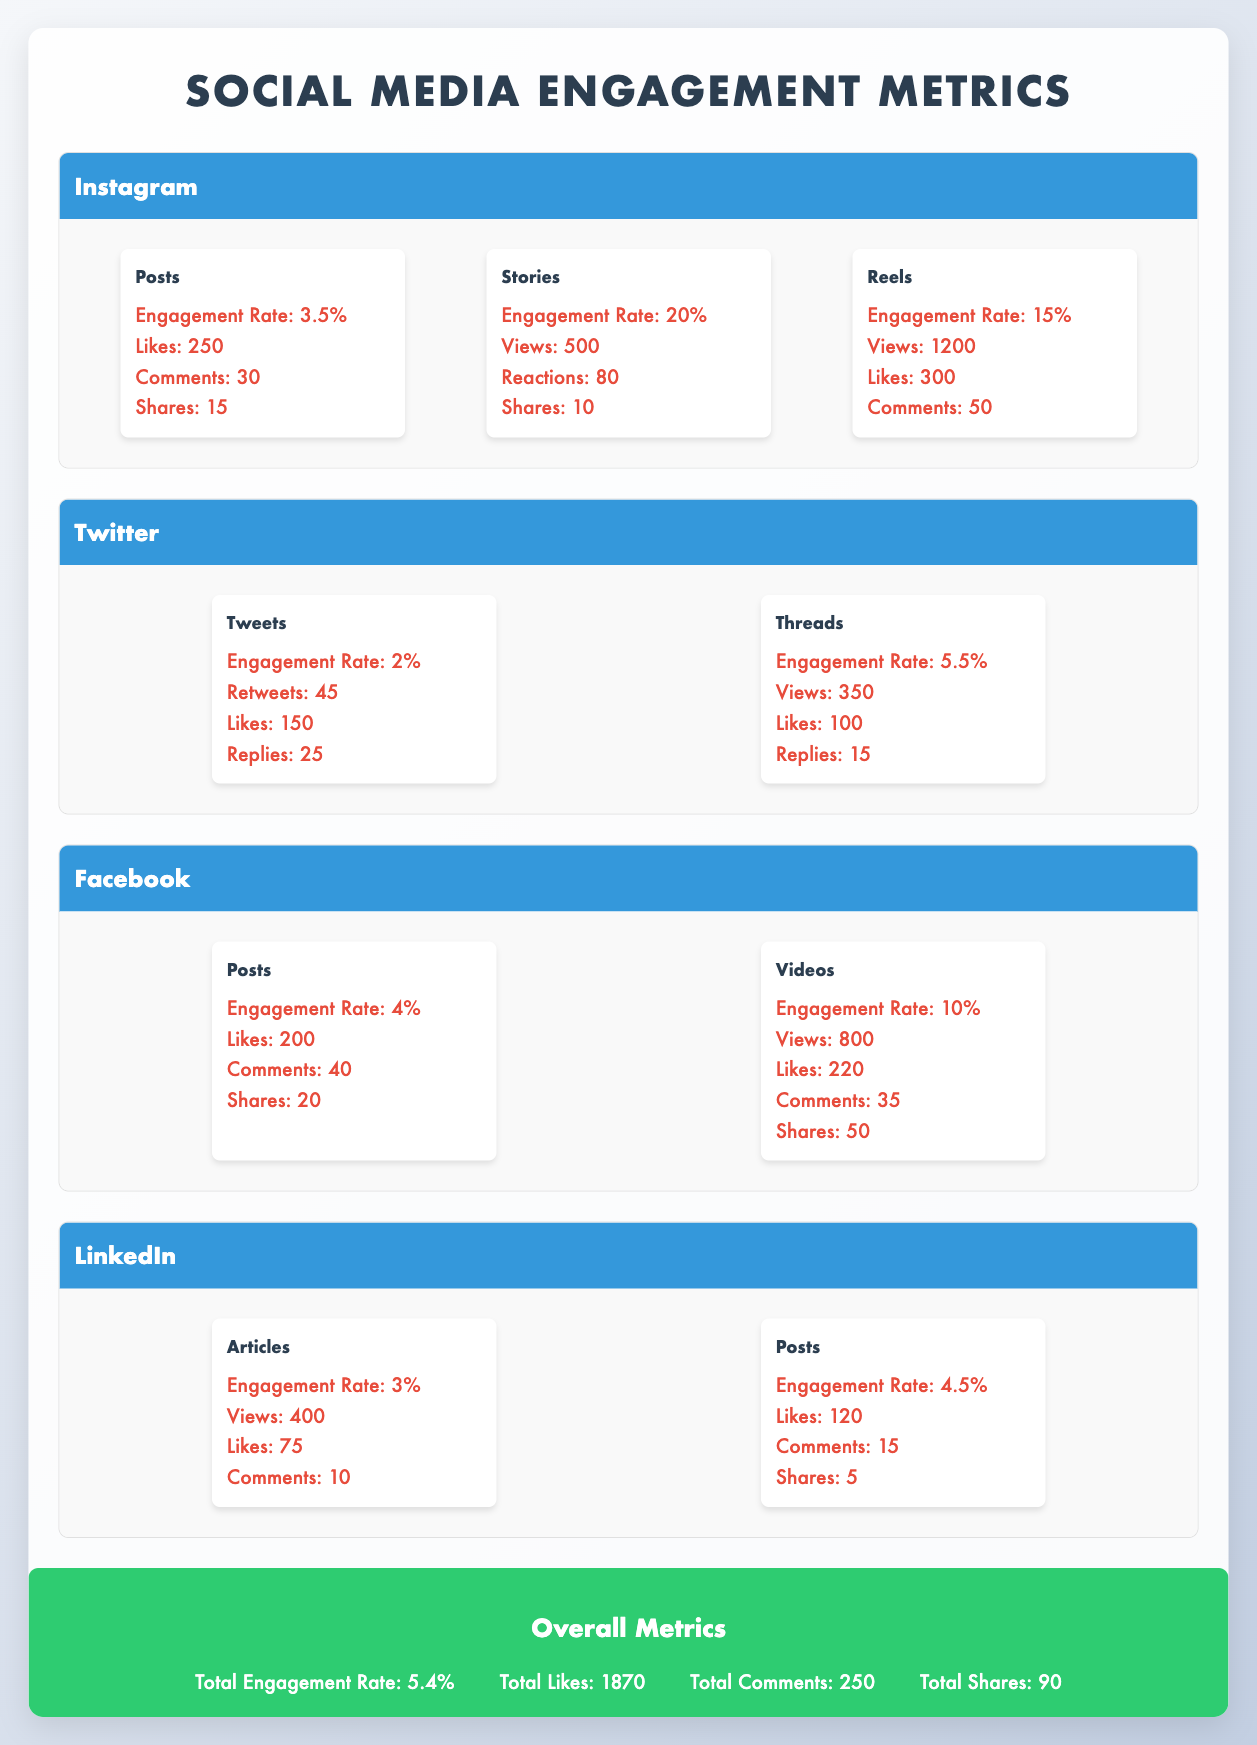What is the engagement rate for Instagram Stories? The engagement rate for Instagram Stories is explicitly stated in the table under "Instagram" and "Stories," which is 20.0%.
Answer: 20.0% What type of content on Facebook has the highest engagement rate? To find the content type with the highest engagement rate on Facebook, we look at the engagement rates for both Posts (4.0%) and Videos (10.0%). The Videos have the highest engagement rate.
Answer: Videos How many total likes did you receive across all platforms? The total likes across all platforms can be calculated by adding the likes from Instagram (250), Twitter (150), Facebook (200), and LinkedIn (120), which gives us 250 + 150 + 200 + 120 = 720 likes.
Answer: 720 Is the engagement rate for LinkedIn Articles higher than that for Twitter Tweets? The engagement rate for LinkedIn Articles is 3.0%, while for Twitter Tweets it is 2.0%. Since 3.0% is greater than 2.0%, this statement is true.
Answer: Yes Which platform has the highest number of shares, and what is the total number of shares for that platform? Looking at the shares for each platform, Instagram has 15 shares from Posts and 10 from Stories for a total of 25; Twitter has 45 retweets from Tweets; Facebook has 20 shares from Posts and 50 from Videos for a total of 70; LinkedIn has 5 shares from Posts. The highest total is Facebook with 70 shares.
Answer: Facebook, 70 What is the average engagement rate for all platforms? The engagement rates to consider are: Instagram (3.5%), Twitter (2.0%), Facebook (4.0%), and LinkedIn (4.5%). The sum is 3.5 + 2.0 + 4.0 + 4.5 = 14.0%. There are 4 platforms, so the average engagement rate is 14.0% / 4 = 3.5%.
Answer: 3.5% Are there more total likes on Instagram or Facebook? Total likes on Instagram is 250, and on Facebook, it is 200. Since 250 is greater than 200, Instagram has more likes.
Answer: Instagram What percentage of total shares comes from Facebook content? Total shares from Facebook is 70, and the total shares across all platforms is 90. The calculation is (70/90) * 100 = 77.78%.
Answer: 77.78% 